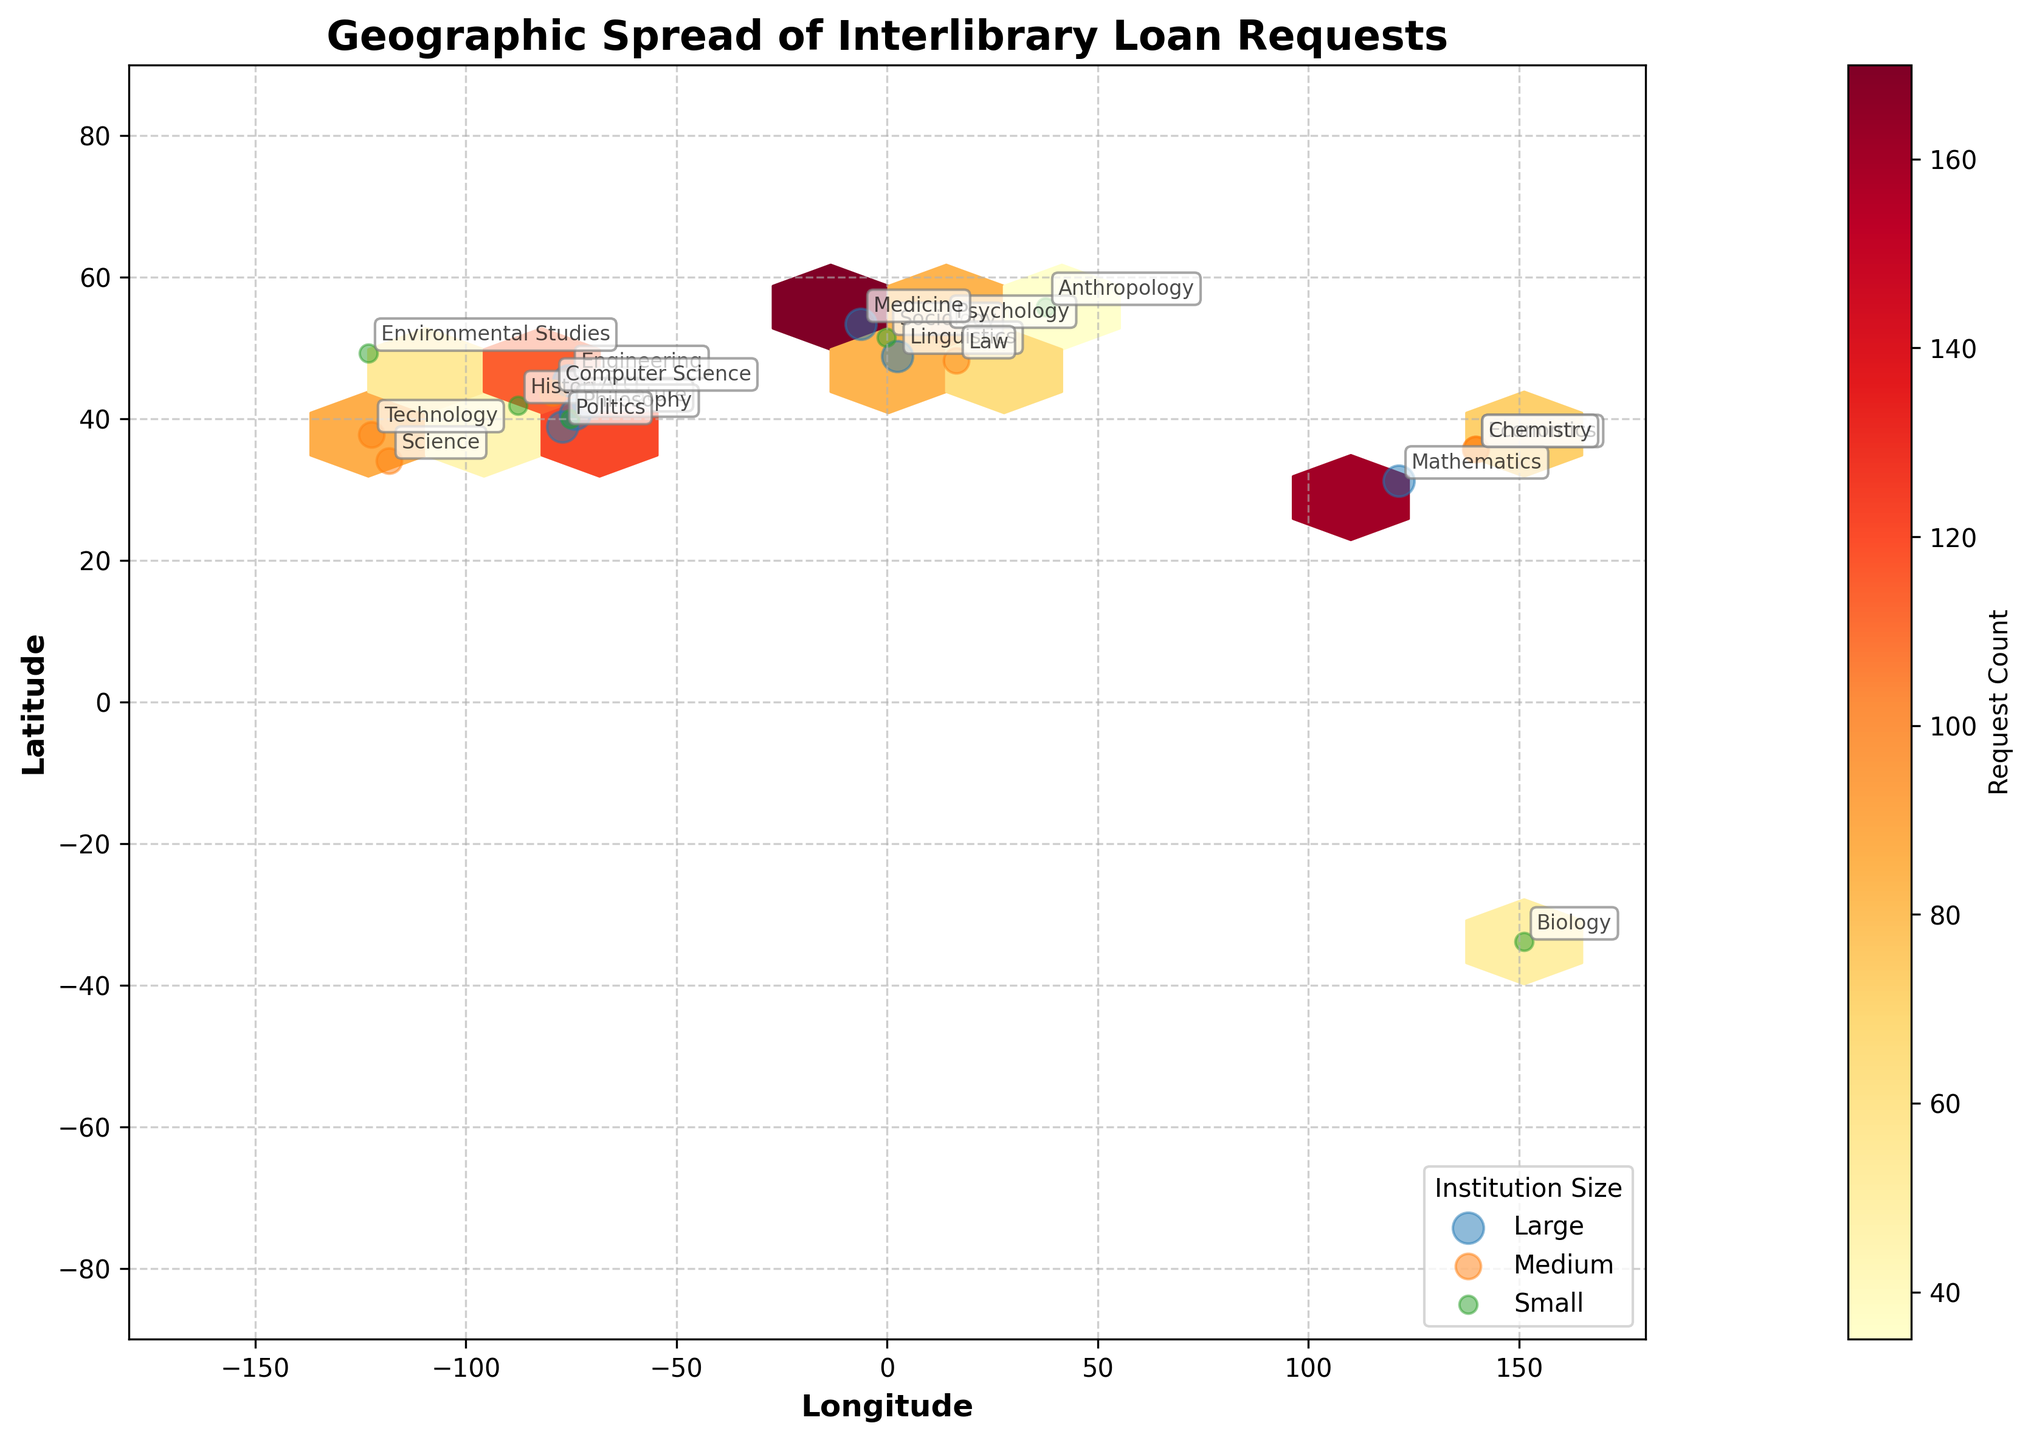What is the title of the plot? The title is displayed at the top of the plot, indicating the main theme or context of the visual representation.
Answer: Geographic Spread of Interlibrary Loan Requests What are the labels on the x-axis and y-axis? The labels are found along each axis, providing details about the dimensions being measured. The x-axis represents 'Longitude' and the y-axis represents 'Latitude'.
Answer: Longitude and Latitude Which subject has the highest request count and where is it located? By examining the color intensity and annotations, we can identify the subject with the highest request count among the hexagons. The 'Politics' subject in Washington, D.C. has the highest count.
Answer: Politics in Washington, D.C How many institution sizes are represented, and what are they? The legend at the bottom right corner categorizes institution sizes, showing three distinct groups: Small, Medium, and Large.
Answer: Three: Small, Medium, and Large Which institution size has the highest concentration of interlibrary loan requests in the Eastern Hemisphere? Focus on the detailed annotations and color intensity in the Eastern Hemisphere. The 'Large' institutions have a noticeable concentration, including 'Economics' in Tokyo and 'Mathematics' in Shanghai.
Answer: Large Within the United States, which city has the lowest request count and what is the subject? Looking at the annotations within the bounded U.S. region, 'Philosophy' in Philadelphia has the lowest count among the U.S. cities.
Answer: Philosophy in Philadelphia Between 'Technology' and 'Biology', which subject has more loan requests and where are they located? Compare the colors and annotations for both subjects. 'Technology' in San Francisco has more requests compared to 'Biology' in Sydney.
Answer: Technology in San Francisco What is the total number of interlibrary loan requests for 'Large' institutions? Sum the request counts for all large institutions: 150 (Literature) + 120 (Art) + 185 (Politics) + 130 (Linguistics) + 160 (Mathematics) + 140 (Engineering) + 170 (Medicine) = 1055.
Answer: 1055 How does the geographic spread of 'Science' requests compare to 'Art' requests? Examine the locations and color intensity for both subjects. 'Science' requests are concentrated in Los Angeles (Medium) and less spread, while 'Art' requests (Large) are mainly in Boston and have higher concentration within a singular spot.
Answer: 'Science' requests are more concentrated in Los Angeles; 'Art' requests are mainly in one location, Boston What is the average request count of medium-sized institutions represented on the plot? Calculate the average by summing the counts for medium-sized institutions and dividing by the number of them. (80 (Science) + 95 (Technology) + 70 (Economics) + 85 (Psychology) + 75 (Chemistry) + 90 (Computer Science) + 65 (Law)) / 7 = 560 / 7 = 80
Answer: 80 